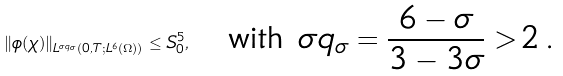Convert formula to latex. <formula><loc_0><loc_0><loc_500><loc_500>\| \phi ( \chi ) \| _ { L ^ { \sigma q _ { \sigma } } ( 0 , T ; L ^ { 6 } ( \Omega ) ) } \leq S _ { 0 } ^ { 5 } , \quad \text {with $\sigma q_{\sigma} = \frac{6-\sigma}{3-3\sigma}>2$\,.}</formula> 